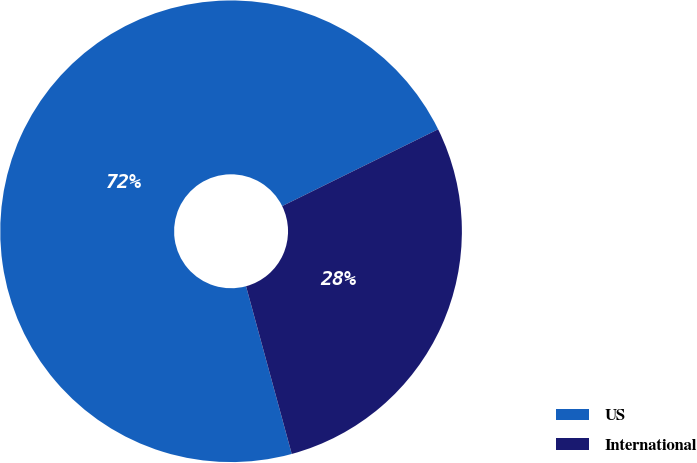Convert chart to OTSL. <chart><loc_0><loc_0><loc_500><loc_500><pie_chart><fcel>US<fcel>International<nl><fcel>71.95%<fcel>28.05%<nl></chart> 